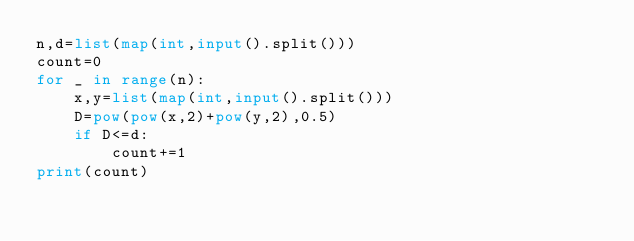<code> <loc_0><loc_0><loc_500><loc_500><_Python_>n,d=list(map(int,input().split()))
count=0
for _ in range(n):
    x,y=list(map(int,input().split()))
    D=pow(pow(x,2)+pow(y,2),0.5)
    if D<=d:
        count+=1
print(count)</code> 